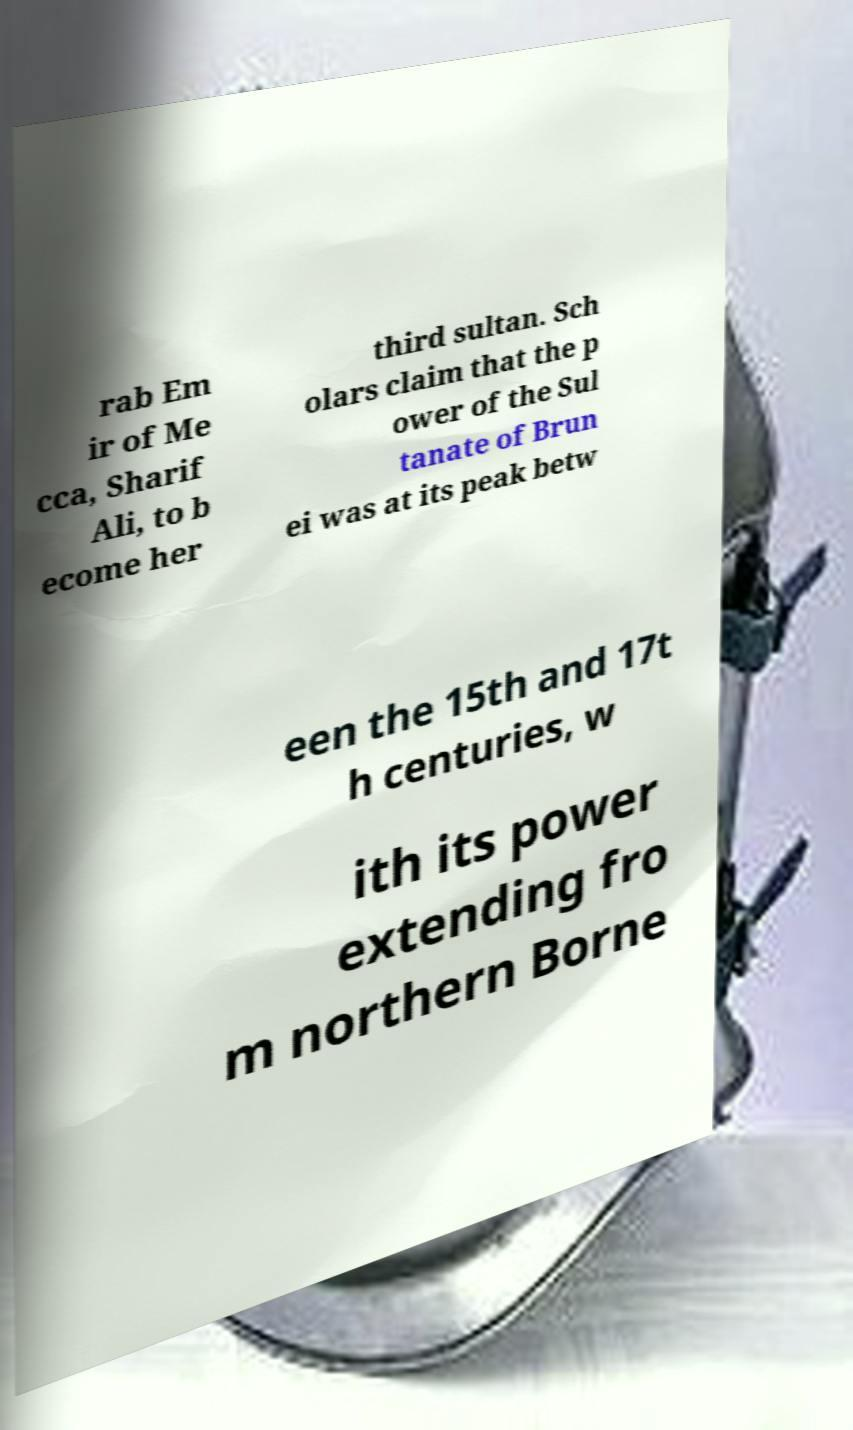Can you read and provide the text displayed in the image?This photo seems to have some interesting text. Can you extract and type it out for me? rab Em ir of Me cca, Sharif Ali, to b ecome her third sultan. Sch olars claim that the p ower of the Sul tanate of Brun ei was at its peak betw een the 15th and 17t h centuries, w ith its power extending fro m northern Borne 